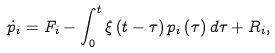Convert formula to latex. <formula><loc_0><loc_0><loc_500><loc_500>\dot { p } _ { i } = F _ { i } - \int ^ { t } _ { 0 } \xi \left ( t - \tau \right ) p _ { i } \left ( \tau \right ) d \tau + R _ { i } ,</formula> 